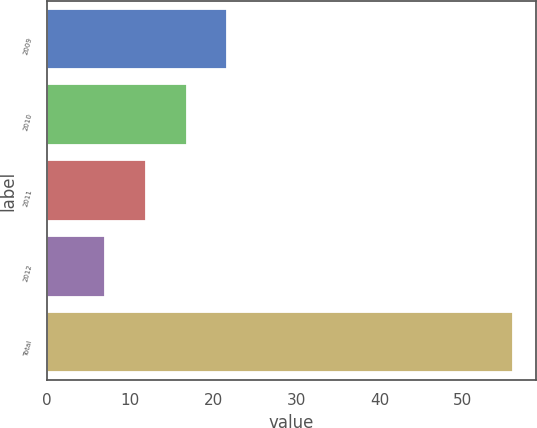Convert chart to OTSL. <chart><loc_0><loc_0><loc_500><loc_500><bar_chart><fcel>2009<fcel>2010<fcel>2011<fcel>2012<fcel>Total<nl><fcel>21.7<fcel>16.8<fcel>11.9<fcel>7<fcel>56<nl></chart> 